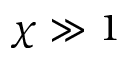<formula> <loc_0><loc_0><loc_500><loc_500>\chi \gg 1</formula> 